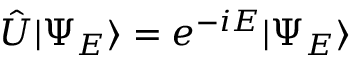Convert formula to latex. <formula><loc_0><loc_0><loc_500><loc_500>\hat { U } | \Psi _ { E } \rangle = e ^ { - i E } | \Psi _ { E } \rangle</formula> 